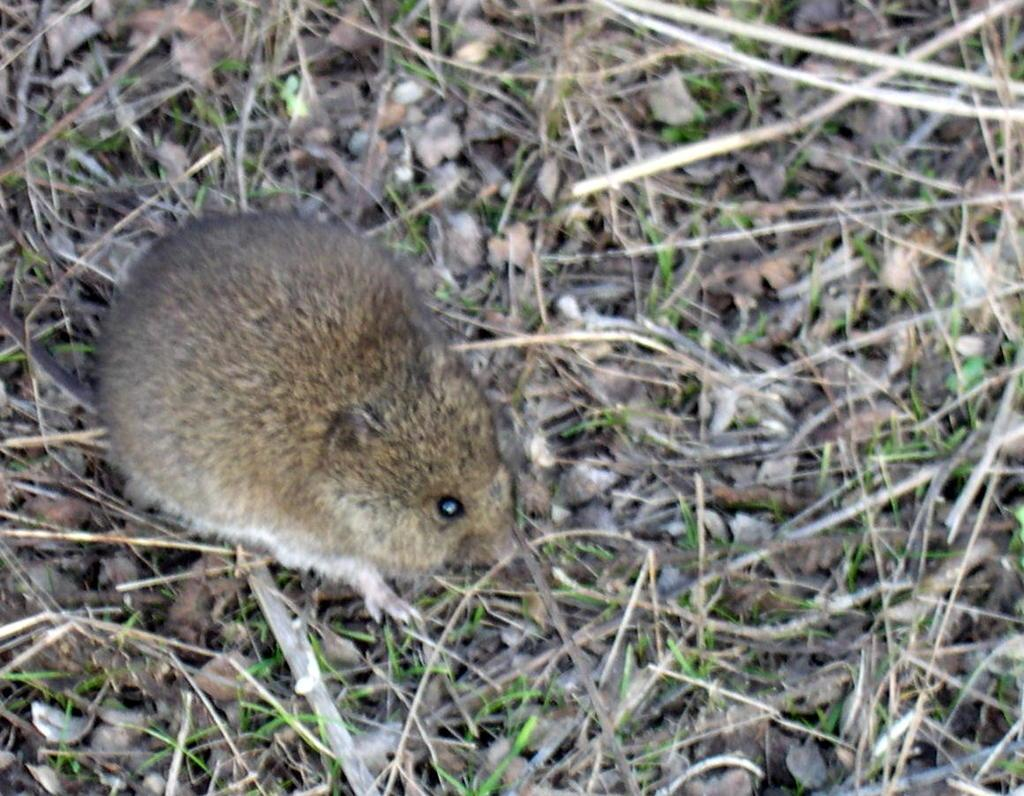What type of animal is in the image? There is an animal in the image, but the specific type cannot be determined from the provided facts. What is surrounding the animal in the image? There are stones, twigs, and grass around the animal in the image. How many eggs can be seen near the animal in the image? There is no mention of eggs in the provided facts, so we cannot determine if any are present in the image. 